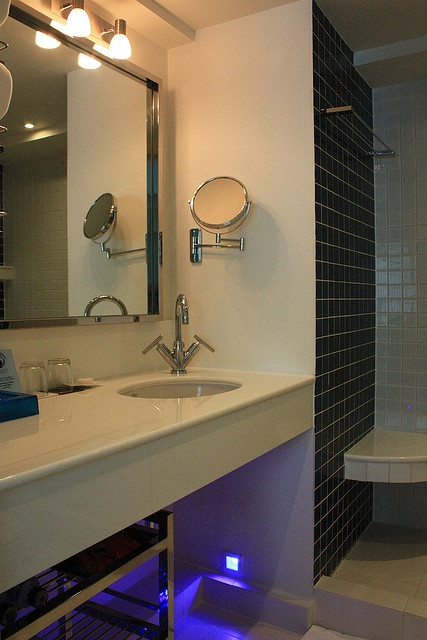Describe the objects in this image and their specific colors. I can see sink in gray, olive, and tan tones, bottle in black, navy, darkblue, and gray tones, cup in gray, olive, and black tones, and cup in gray, olive, and tan tones in this image. 